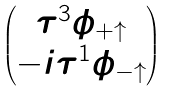Convert formula to latex. <formula><loc_0><loc_0><loc_500><loc_500>\begin{pmatrix} \tau ^ { 3 } \phi _ { + \uparrow } \\ - i \tau ^ { 1 } \phi _ { - \uparrow } \end{pmatrix}</formula> 